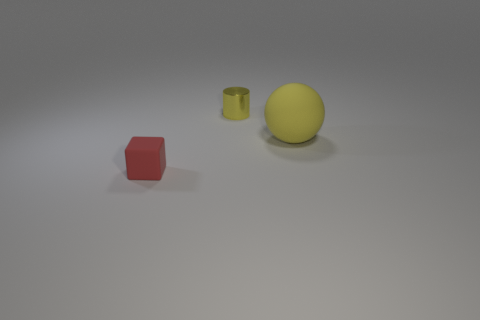Is there anything else that has the same material as the tiny cylinder?
Give a very brief answer. No. How many blue matte cylinders are the same size as the yellow metal cylinder?
Provide a succinct answer. 0. Does the tiny object that is behind the tiny matte thing have the same material as the big thing?
Your answer should be compact. No. There is a tiny matte block to the left of the big rubber sphere; is there a small red matte cube on the right side of it?
Ensure brevity in your answer.  No. Are there more red matte objects behind the small rubber thing than big yellow rubber things that are behind the tiny metallic cylinder?
Keep it short and to the point. No. There is a thing that is made of the same material as the big yellow sphere; what shape is it?
Provide a short and direct response. Cube. Are there more small rubber blocks that are in front of the small red matte thing than large yellow cylinders?
Your answer should be very brief. No. How many other big rubber balls are the same color as the matte sphere?
Your response must be concise. 0. How many other objects are the same color as the large sphere?
Offer a very short reply. 1. Are there more cyan cubes than big rubber things?
Offer a terse response. No. 